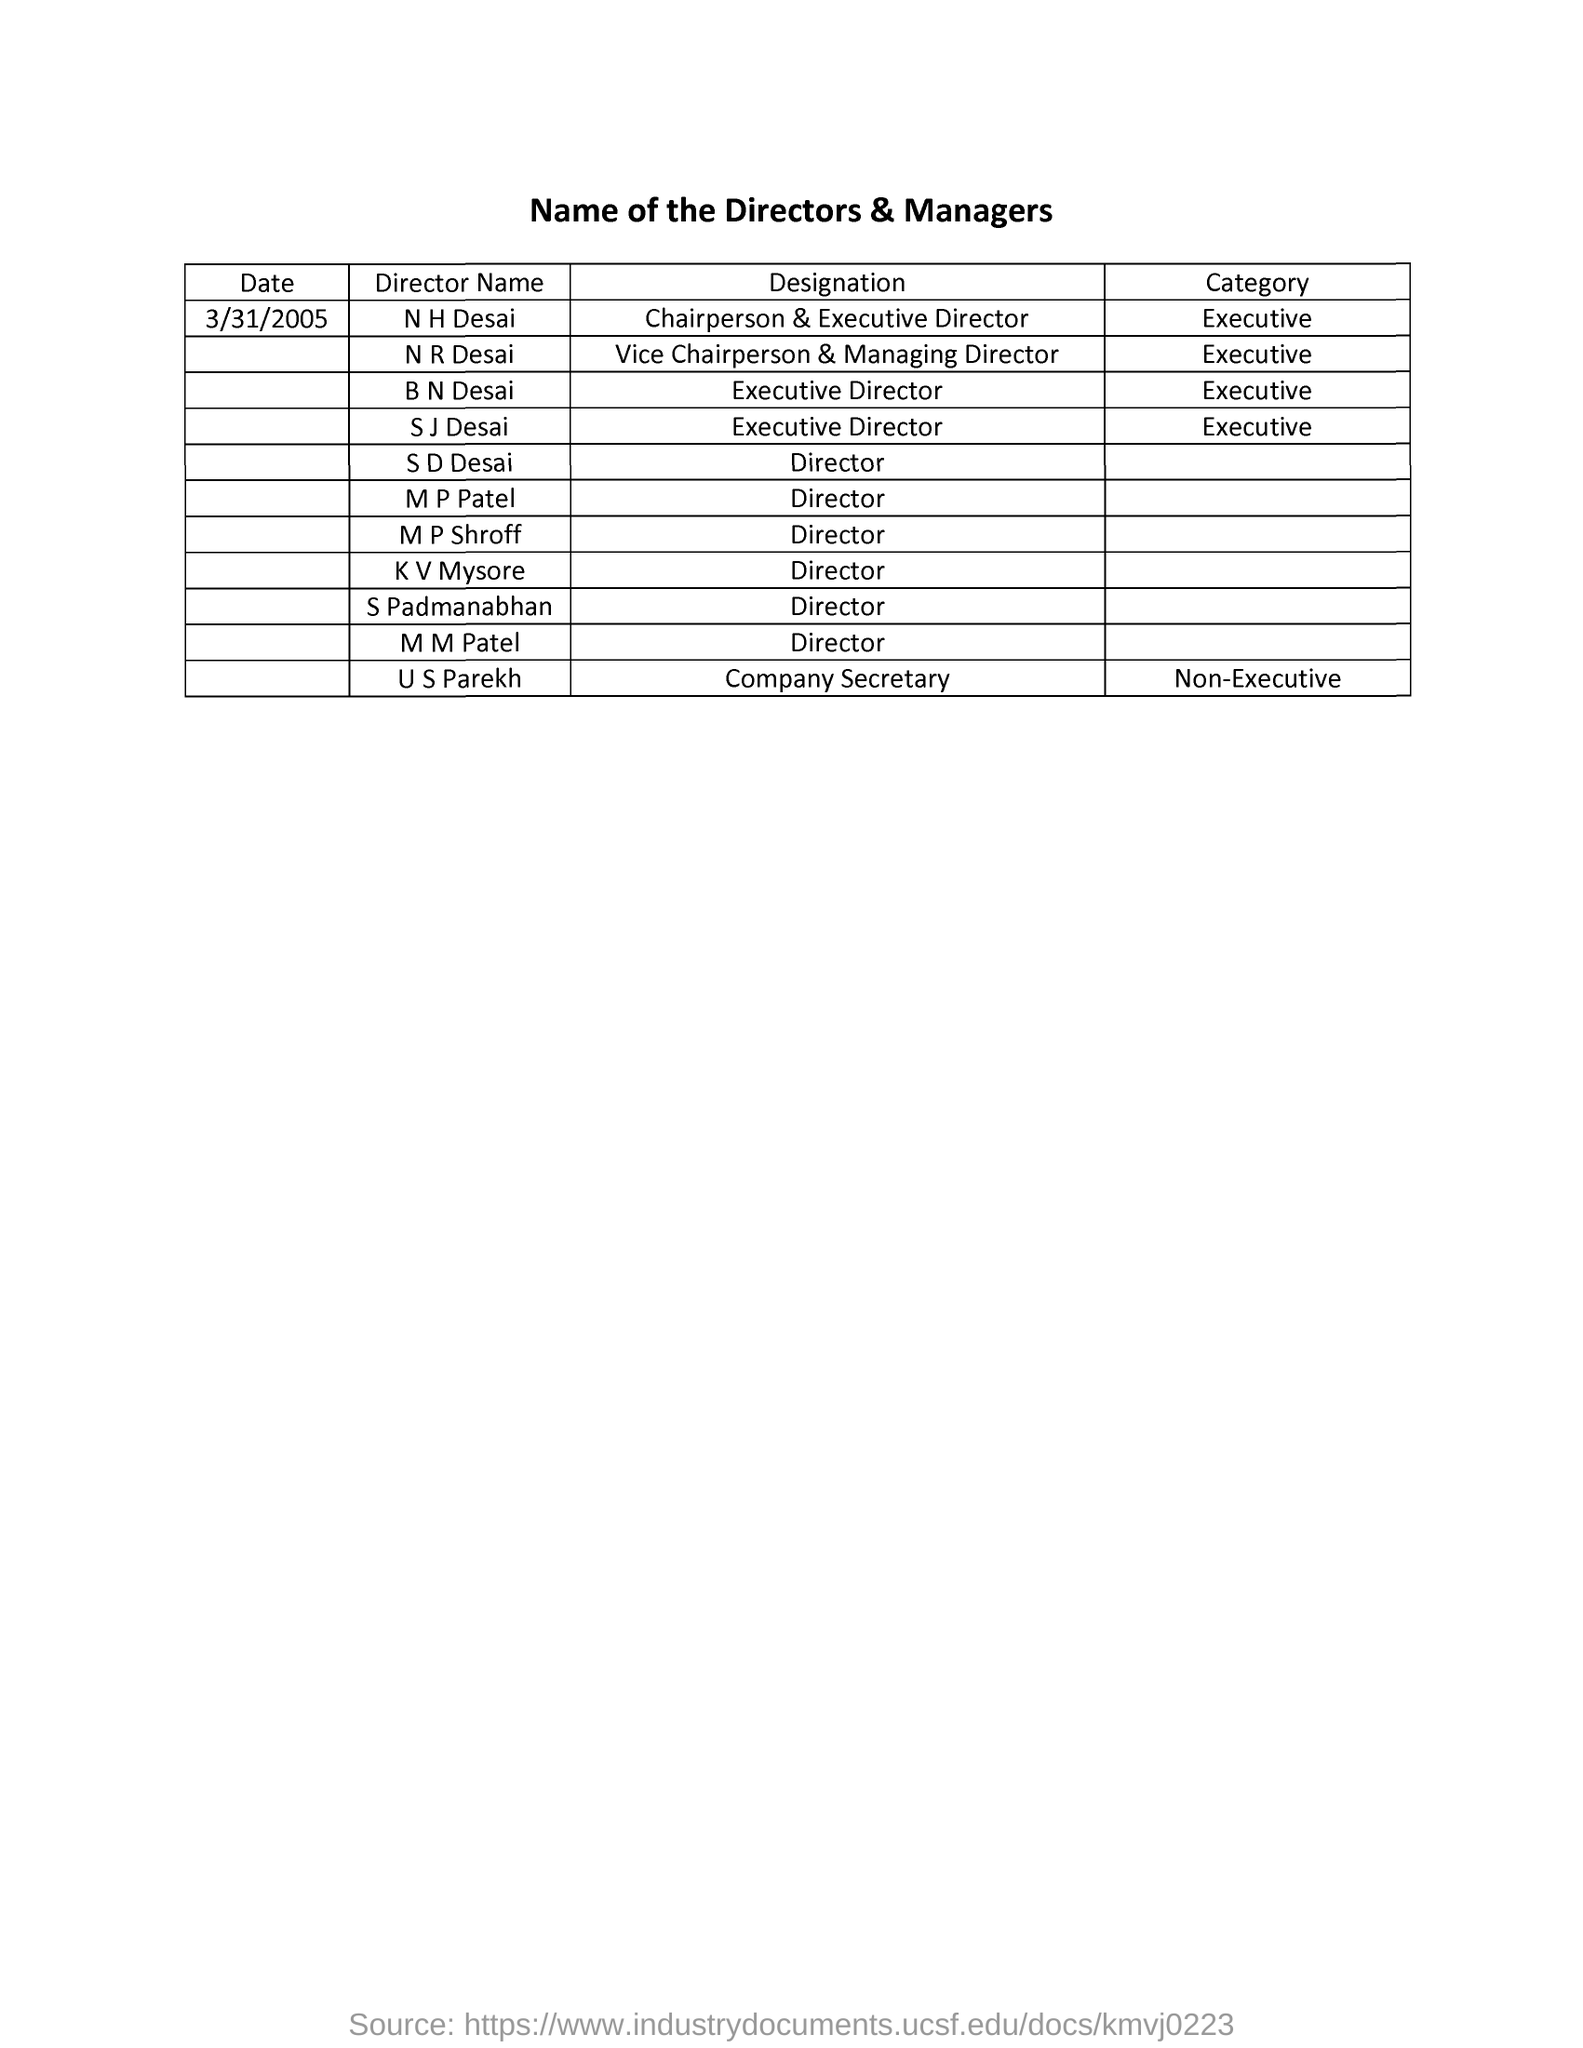what is the category of N R Desai ?
 Executive 